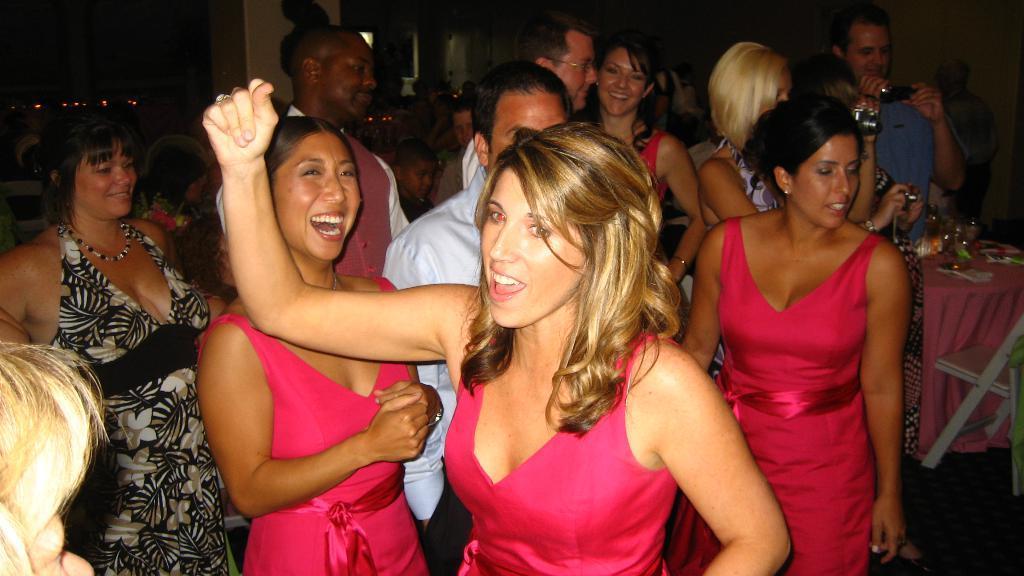Can you describe this image briefly? In this picture, we can see a few people, and two of them are holding camera, we can see the ground and some objects on it, we can see table covered with cloth, and we can see some objects on the table, we can see the chair, and we can see some lights in the top left corner, and we can see some objects on top side of the picture, we can see the wall. 